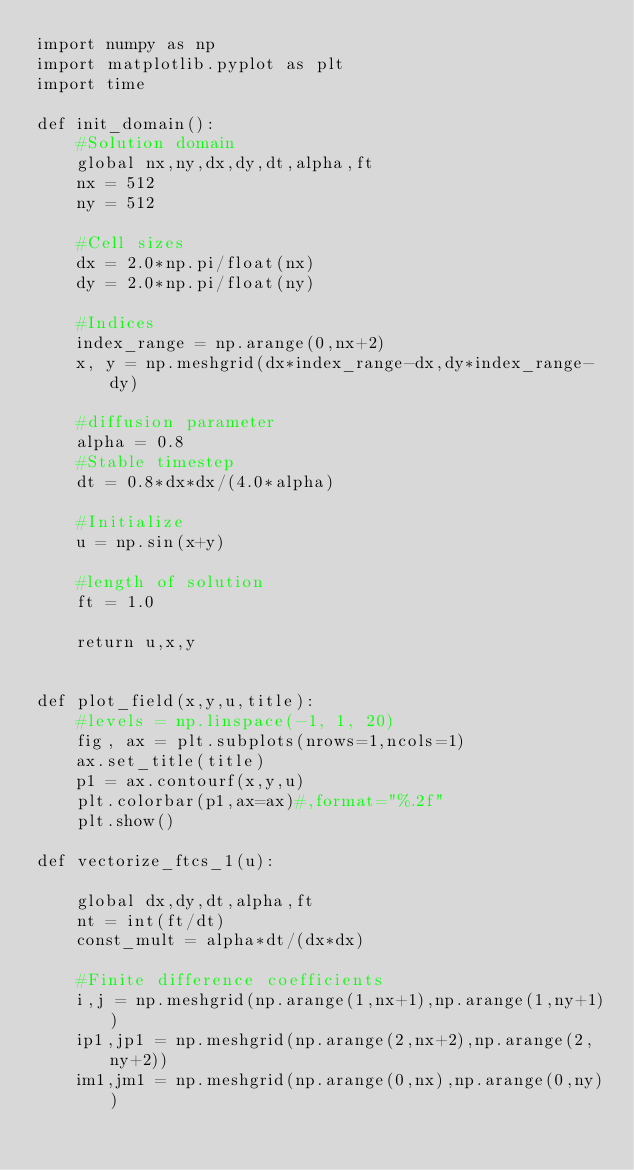Convert code to text. <code><loc_0><loc_0><loc_500><loc_500><_Python_>import numpy as np
import matplotlib.pyplot as plt
import time

def init_domain():
	#Solution domain
	global nx,ny,dx,dy,dt,alpha,ft
	nx = 512
	ny = 512
	
	#Cell sizes
	dx = 2.0*np.pi/float(nx)
	dy = 2.0*np.pi/float(ny)

	#Indices
	index_range = np.arange(0,nx+2)
	x, y = np.meshgrid(dx*index_range-dx,dy*index_range-dy)

	#diffusion parameter
	alpha = 0.8
	#Stable timestep
	dt = 0.8*dx*dx/(4.0*alpha)

	#Initialize
	u = np.sin(x+y)

	#length of solution
	ft = 1.0

	return u,x,y


def plot_field(x,y,u,title):
	#levels = np.linspace(-1, 1, 20)
	fig, ax = plt.subplots(nrows=1,ncols=1)
	ax.set_title(title)
	p1 = ax.contourf(x,y,u)
	plt.colorbar(p1,ax=ax)#,format="%.2f"
	plt.show()

def vectorize_ftcs_1(u):

	global dx,dy,dt,alpha,ft
	nt = int(ft/dt)
	const_mult = alpha*dt/(dx*dx)
	
	#Finite difference coefficients
	i,j = np.meshgrid(np.arange(1,nx+1),np.arange(1,ny+1))
	ip1,jp1 = np.meshgrid(np.arange(2,nx+2),np.arange(2,ny+2))
	im1,jm1 = np.meshgrid(np.arange(0,nx),np.arange(0,ny))
</code> 